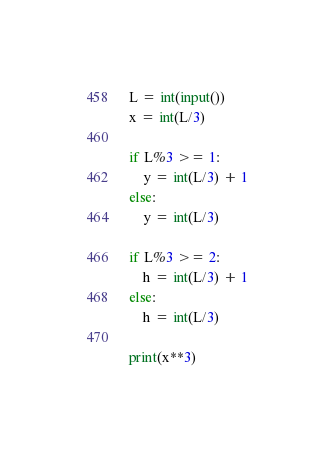Convert code to text. <code><loc_0><loc_0><loc_500><loc_500><_Python_>L = int(input())
x = int(L/3)

if L%3 >= 1:
    y = int(L/3) + 1
else:
    y = int(L/3)

if L%3 >= 2:
    h = int(L/3) + 1
else:
    h = int(L/3)

print(x**3)</code> 